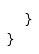Convert code to text. <code><loc_0><loc_0><loc_500><loc_500><_C#_>    }
}</code> 